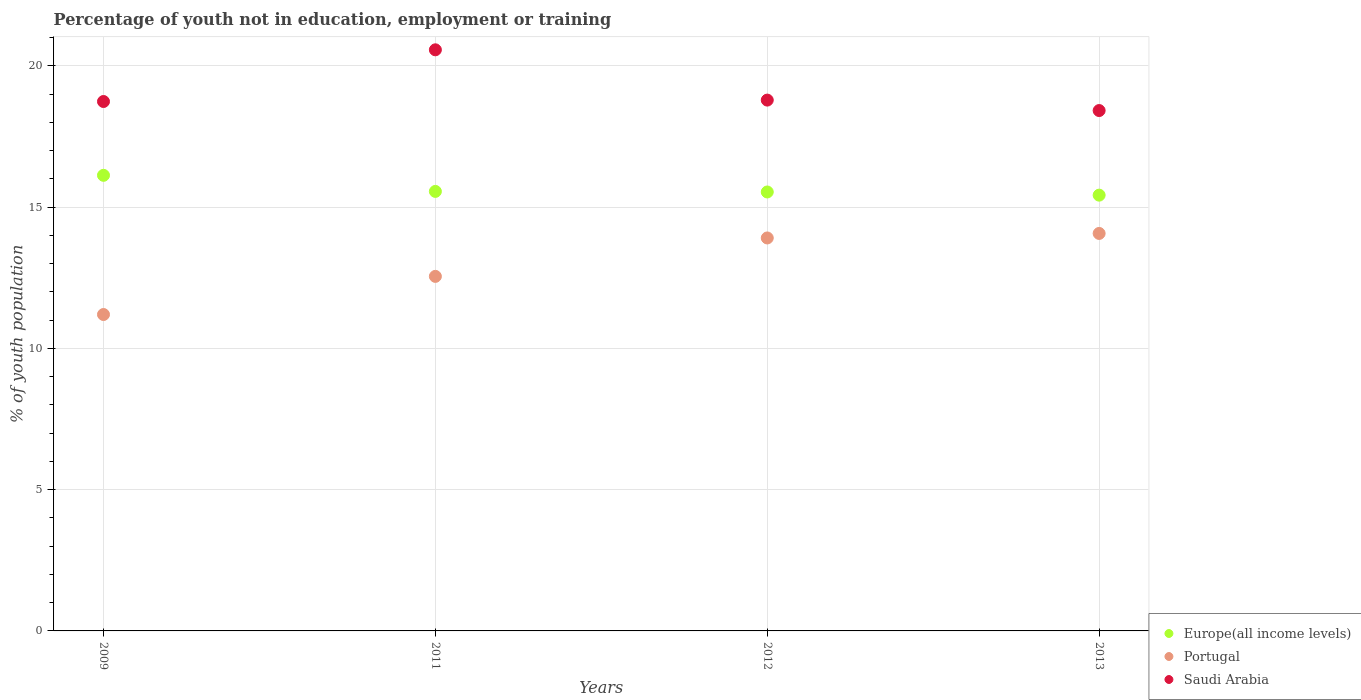How many different coloured dotlines are there?
Your answer should be compact. 3. What is the percentage of unemployed youth population in in Europe(all income levels) in 2009?
Keep it short and to the point. 16.13. Across all years, what is the maximum percentage of unemployed youth population in in Europe(all income levels)?
Provide a succinct answer. 16.13. Across all years, what is the minimum percentage of unemployed youth population in in Portugal?
Keep it short and to the point. 11.2. In which year was the percentage of unemployed youth population in in Saudi Arabia maximum?
Make the answer very short. 2011. What is the total percentage of unemployed youth population in in Europe(all income levels) in the graph?
Keep it short and to the point. 62.65. What is the difference between the percentage of unemployed youth population in in Saudi Arabia in 2009 and that in 2012?
Make the answer very short. -0.05. What is the difference between the percentage of unemployed youth population in in Saudi Arabia in 2009 and the percentage of unemployed youth population in in Portugal in 2012?
Your response must be concise. 4.83. What is the average percentage of unemployed youth population in in Portugal per year?
Keep it short and to the point. 12.93. In the year 2009, what is the difference between the percentage of unemployed youth population in in Portugal and percentage of unemployed youth population in in Saudi Arabia?
Provide a short and direct response. -7.54. In how many years, is the percentage of unemployed youth population in in Portugal greater than 10 %?
Provide a succinct answer. 4. What is the ratio of the percentage of unemployed youth population in in Europe(all income levels) in 2009 to that in 2012?
Provide a short and direct response. 1.04. What is the difference between the highest and the second highest percentage of unemployed youth population in in Portugal?
Your answer should be very brief. 0.16. What is the difference between the highest and the lowest percentage of unemployed youth population in in Europe(all income levels)?
Your answer should be compact. 0.7. Is the sum of the percentage of unemployed youth population in in Europe(all income levels) in 2011 and 2013 greater than the maximum percentage of unemployed youth population in in Saudi Arabia across all years?
Your answer should be compact. Yes. Is it the case that in every year, the sum of the percentage of unemployed youth population in in Europe(all income levels) and percentage of unemployed youth population in in Portugal  is greater than the percentage of unemployed youth population in in Saudi Arabia?
Your response must be concise. Yes. Does the percentage of unemployed youth population in in Saudi Arabia monotonically increase over the years?
Make the answer very short. No. Is the percentage of unemployed youth population in in Europe(all income levels) strictly greater than the percentage of unemployed youth population in in Portugal over the years?
Make the answer very short. Yes. Is the percentage of unemployed youth population in in Portugal strictly less than the percentage of unemployed youth population in in Saudi Arabia over the years?
Offer a terse response. Yes. How many dotlines are there?
Provide a short and direct response. 3. What is the difference between two consecutive major ticks on the Y-axis?
Make the answer very short. 5. Does the graph contain any zero values?
Your answer should be compact. No. Where does the legend appear in the graph?
Your answer should be compact. Bottom right. How many legend labels are there?
Keep it short and to the point. 3. How are the legend labels stacked?
Offer a terse response. Vertical. What is the title of the graph?
Offer a very short reply. Percentage of youth not in education, employment or training. Does "Switzerland" appear as one of the legend labels in the graph?
Provide a succinct answer. No. What is the label or title of the X-axis?
Offer a terse response. Years. What is the label or title of the Y-axis?
Your answer should be compact. % of youth population. What is the % of youth population in Europe(all income levels) in 2009?
Keep it short and to the point. 16.13. What is the % of youth population of Portugal in 2009?
Your answer should be compact. 11.2. What is the % of youth population of Saudi Arabia in 2009?
Offer a very short reply. 18.74. What is the % of youth population in Europe(all income levels) in 2011?
Provide a succinct answer. 15.56. What is the % of youth population of Portugal in 2011?
Keep it short and to the point. 12.55. What is the % of youth population in Saudi Arabia in 2011?
Make the answer very short. 20.57. What is the % of youth population of Europe(all income levels) in 2012?
Provide a succinct answer. 15.54. What is the % of youth population of Portugal in 2012?
Offer a very short reply. 13.91. What is the % of youth population of Saudi Arabia in 2012?
Keep it short and to the point. 18.79. What is the % of youth population of Europe(all income levels) in 2013?
Your answer should be very brief. 15.43. What is the % of youth population of Portugal in 2013?
Ensure brevity in your answer.  14.07. What is the % of youth population in Saudi Arabia in 2013?
Your answer should be compact. 18.42. Across all years, what is the maximum % of youth population in Europe(all income levels)?
Ensure brevity in your answer.  16.13. Across all years, what is the maximum % of youth population in Portugal?
Provide a short and direct response. 14.07. Across all years, what is the maximum % of youth population of Saudi Arabia?
Your response must be concise. 20.57. Across all years, what is the minimum % of youth population of Europe(all income levels)?
Make the answer very short. 15.43. Across all years, what is the minimum % of youth population of Portugal?
Your answer should be compact. 11.2. Across all years, what is the minimum % of youth population of Saudi Arabia?
Your response must be concise. 18.42. What is the total % of youth population of Europe(all income levels) in the graph?
Offer a very short reply. 62.65. What is the total % of youth population in Portugal in the graph?
Your answer should be very brief. 51.73. What is the total % of youth population in Saudi Arabia in the graph?
Keep it short and to the point. 76.52. What is the difference between the % of youth population in Europe(all income levels) in 2009 and that in 2011?
Your answer should be very brief. 0.57. What is the difference between the % of youth population in Portugal in 2009 and that in 2011?
Provide a succinct answer. -1.35. What is the difference between the % of youth population of Saudi Arabia in 2009 and that in 2011?
Provide a succinct answer. -1.83. What is the difference between the % of youth population of Europe(all income levels) in 2009 and that in 2012?
Ensure brevity in your answer.  0.59. What is the difference between the % of youth population in Portugal in 2009 and that in 2012?
Ensure brevity in your answer.  -2.71. What is the difference between the % of youth population of Europe(all income levels) in 2009 and that in 2013?
Offer a terse response. 0.7. What is the difference between the % of youth population in Portugal in 2009 and that in 2013?
Offer a very short reply. -2.87. What is the difference between the % of youth population in Saudi Arabia in 2009 and that in 2013?
Ensure brevity in your answer.  0.32. What is the difference between the % of youth population in Europe(all income levels) in 2011 and that in 2012?
Keep it short and to the point. 0.02. What is the difference between the % of youth population of Portugal in 2011 and that in 2012?
Your response must be concise. -1.36. What is the difference between the % of youth population of Saudi Arabia in 2011 and that in 2012?
Offer a very short reply. 1.78. What is the difference between the % of youth population in Europe(all income levels) in 2011 and that in 2013?
Provide a succinct answer. 0.13. What is the difference between the % of youth population in Portugal in 2011 and that in 2013?
Your response must be concise. -1.52. What is the difference between the % of youth population of Saudi Arabia in 2011 and that in 2013?
Ensure brevity in your answer.  2.15. What is the difference between the % of youth population in Europe(all income levels) in 2012 and that in 2013?
Offer a very short reply. 0.11. What is the difference between the % of youth population in Portugal in 2012 and that in 2013?
Provide a succinct answer. -0.16. What is the difference between the % of youth population of Saudi Arabia in 2012 and that in 2013?
Offer a very short reply. 0.37. What is the difference between the % of youth population in Europe(all income levels) in 2009 and the % of youth population in Portugal in 2011?
Your answer should be compact. 3.58. What is the difference between the % of youth population of Europe(all income levels) in 2009 and the % of youth population of Saudi Arabia in 2011?
Your answer should be very brief. -4.44. What is the difference between the % of youth population in Portugal in 2009 and the % of youth population in Saudi Arabia in 2011?
Your answer should be very brief. -9.37. What is the difference between the % of youth population of Europe(all income levels) in 2009 and the % of youth population of Portugal in 2012?
Your response must be concise. 2.22. What is the difference between the % of youth population in Europe(all income levels) in 2009 and the % of youth population in Saudi Arabia in 2012?
Provide a succinct answer. -2.66. What is the difference between the % of youth population of Portugal in 2009 and the % of youth population of Saudi Arabia in 2012?
Offer a very short reply. -7.59. What is the difference between the % of youth population of Europe(all income levels) in 2009 and the % of youth population of Portugal in 2013?
Your answer should be compact. 2.06. What is the difference between the % of youth population of Europe(all income levels) in 2009 and the % of youth population of Saudi Arabia in 2013?
Offer a terse response. -2.29. What is the difference between the % of youth population in Portugal in 2009 and the % of youth population in Saudi Arabia in 2013?
Give a very brief answer. -7.22. What is the difference between the % of youth population in Europe(all income levels) in 2011 and the % of youth population in Portugal in 2012?
Make the answer very short. 1.65. What is the difference between the % of youth population in Europe(all income levels) in 2011 and the % of youth population in Saudi Arabia in 2012?
Offer a very short reply. -3.23. What is the difference between the % of youth population of Portugal in 2011 and the % of youth population of Saudi Arabia in 2012?
Give a very brief answer. -6.24. What is the difference between the % of youth population of Europe(all income levels) in 2011 and the % of youth population of Portugal in 2013?
Your answer should be compact. 1.49. What is the difference between the % of youth population in Europe(all income levels) in 2011 and the % of youth population in Saudi Arabia in 2013?
Provide a short and direct response. -2.86. What is the difference between the % of youth population in Portugal in 2011 and the % of youth population in Saudi Arabia in 2013?
Make the answer very short. -5.87. What is the difference between the % of youth population in Europe(all income levels) in 2012 and the % of youth population in Portugal in 2013?
Provide a succinct answer. 1.47. What is the difference between the % of youth population of Europe(all income levels) in 2012 and the % of youth population of Saudi Arabia in 2013?
Your answer should be very brief. -2.88. What is the difference between the % of youth population in Portugal in 2012 and the % of youth population in Saudi Arabia in 2013?
Your answer should be very brief. -4.51. What is the average % of youth population in Europe(all income levels) per year?
Keep it short and to the point. 15.66. What is the average % of youth population of Portugal per year?
Offer a terse response. 12.93. What is the average % of youth population in Saudi Arabia per year?
Provide a succinct answer. 19.13. In the year 2009, what is the difference between the % of youth population of Europe(all income levels) and % of youth population of Portugal?
Ensure brevity in your answer.  4.93. In the year 2009, what is the difference between the % of youth population in Europe(all income levels) and % of youth population in Saudi Arabia?
Offer a very short reply. -2.61. In the year 2009, what is the difference between the % of youth population of Portugal and % of youth population of Saudi Arabia?
Your response must be concise. -7.54. In the year 2011, what is the difference between the % of youth population of Europe(all income levels) and % of youth population of Portugal?
Keep it short and to the point. 3.01. In the year 2011, what is the difference between the % of youth population of Europe(all income levels) and % of youth population of Saudi Arabia?
Your answer should be very brief. -5.01. In the year 2011, what is the difference between the % of youth population of Portugal and % of youth population of Saudi Arabia?
Offer a very short reply. -8.02. In the year 2012, what is the difference between the % of youth population in Europe(all income levels) and % of youth population in Portugal?
Your answer should be compact. 1.63. In the year 2012, what is the difference between the % of youth population of Europe(all income levels) and % of youth population of Saudi Arabia?
Provide a short and direct response. -3.25. In the year 2012, what is the difference between the % of youth population in Portugal and % of youth population in Saudi Arabia?
Make the answer very short. -4.88. In the year 2013, what is the difference between the % of youth population in Europe(all income levels) and % of youth population in Portugal?
Your answer should be very brief. 1.36. In the year 2013, what is the difference between the % of youth population of Europe(all income levels) and % of youth population of Saudi Arabia?
Give a very brief answer. -2.99. In the year 2013, what is the difference between the % of youth population in Portugal and % of youth population in Saudi Arabia?
Ensure brevity in your answer.  -4.35. What is the ratio of the % of youth population of Europe(all income levels) in 2009 to that in 2011?
Offer a very short reply. 1.04. What is the ratio of the % of youth population in Portugal in 2009 to that in 2011?
Provide a short and direct response. 0.89. What is the ratio of the % of youth population in Saudi Arabia in 2009 to that in 2011?
Offer a terse response. 0.91. What is the ratio of the % of youth population of Europe(all income levels) in 2009 to that in 2012?
Offer a very short reply. 1.04. What is the ratio of the % of youth population in Portugal in 2009 to that in 2012?
Your response must be concise. 0.81. What is the ratio of the % of youth population in Saudi Arabia in 2009 to that in 2012?
Offer a very short reply. 1. What is the ratio of the % of youth population of Europe(all income levels) in 2009 to that in 2013?
Offer a terse response. 1.05. What is the ratio of the % of youth population of Portugal in 2009 to that in 2013?
Give a very brief answer. 0.8. What is the ratio of the % of youth population of Saudi Arabia in 2009 to that in 2013?
Keep it short and to the point. 1.02. What is the ratio of the % of youth population in Europe(all income levels) in 2011 to that in 2012?
Give a very brief answer. 1. What is the ratio of the % of youth population of Portugal in 2011 to that in 2012?
Offer a very short reply. 0.9. What is the ratio of the % of youth population in Saudi Arabia in 2011 to that in 2012?
Ensure brevity in your answer.  1.09. What is the ratio of the % of youth population of Europe(all income levels) in 2011 to that in 2013?
Provide a short and direct response. 1.01. What is the ratio of the % of youth population of Portugal in 2011 to that in 2013?
Provide a short and direct response. 0.89. What is the ratio of the % of youth population of Saudi Arabia in 2011 to that in 2013?
Ensure brevity in your answer.  1.12. What is the ratio of the % of youth population in Europe(all income levels) in 2012 to that in 2013?
Keep it short and to the point. 1.01. What is the ratio of the % of youth population of Portugal in 2012 to that in 2013?
Your response must be concise. 0.99. What is the ratio of the % of youth population in Saudi Arabia in 2012 to that in 2013?
Provide a succinct answer. 1.02. What is the difference between the highest and the second highest % of youth population in Europe(all income levels)?
Offer a very short reply. 0.57. What is the difference between the highest and the second highest % of youth population of Portugal?
Keep it short and to the point. 0.16. What is the difference between the highest and the second highest % of youth population in Saudi Arabia?
Offer a terse response. 1.78. What is the difference between the highest and the lowest % of youth population in Europe(all income levels)?
Keep it short and to the point. 0.7. What is the difference between the highest and the lowest % of youth population in Portugal?
Give a very brief answer. 2.87. What is the difference between the highest and the lowest % of youth population in Saudi Arabia?
Make the answer very short. 2.15. 